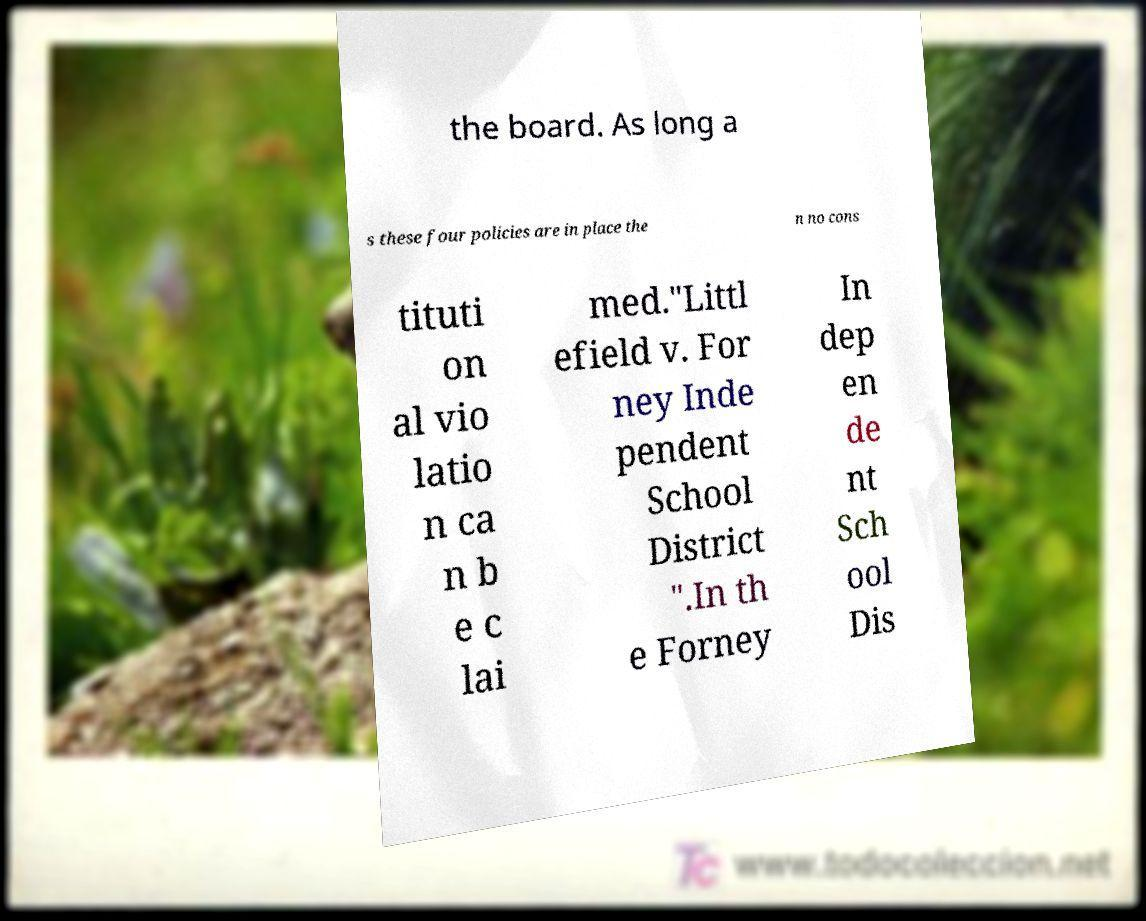Could you assist in decoding the text presented in this image and type it out clearly? the board. As long a s these four policies are in place the n no cons tituti on al vio latio n ca n b e c lai med."Littl efield v. For ney Inde pendent School District ".In th e Forney In dep en de nt Sch ool Dis 